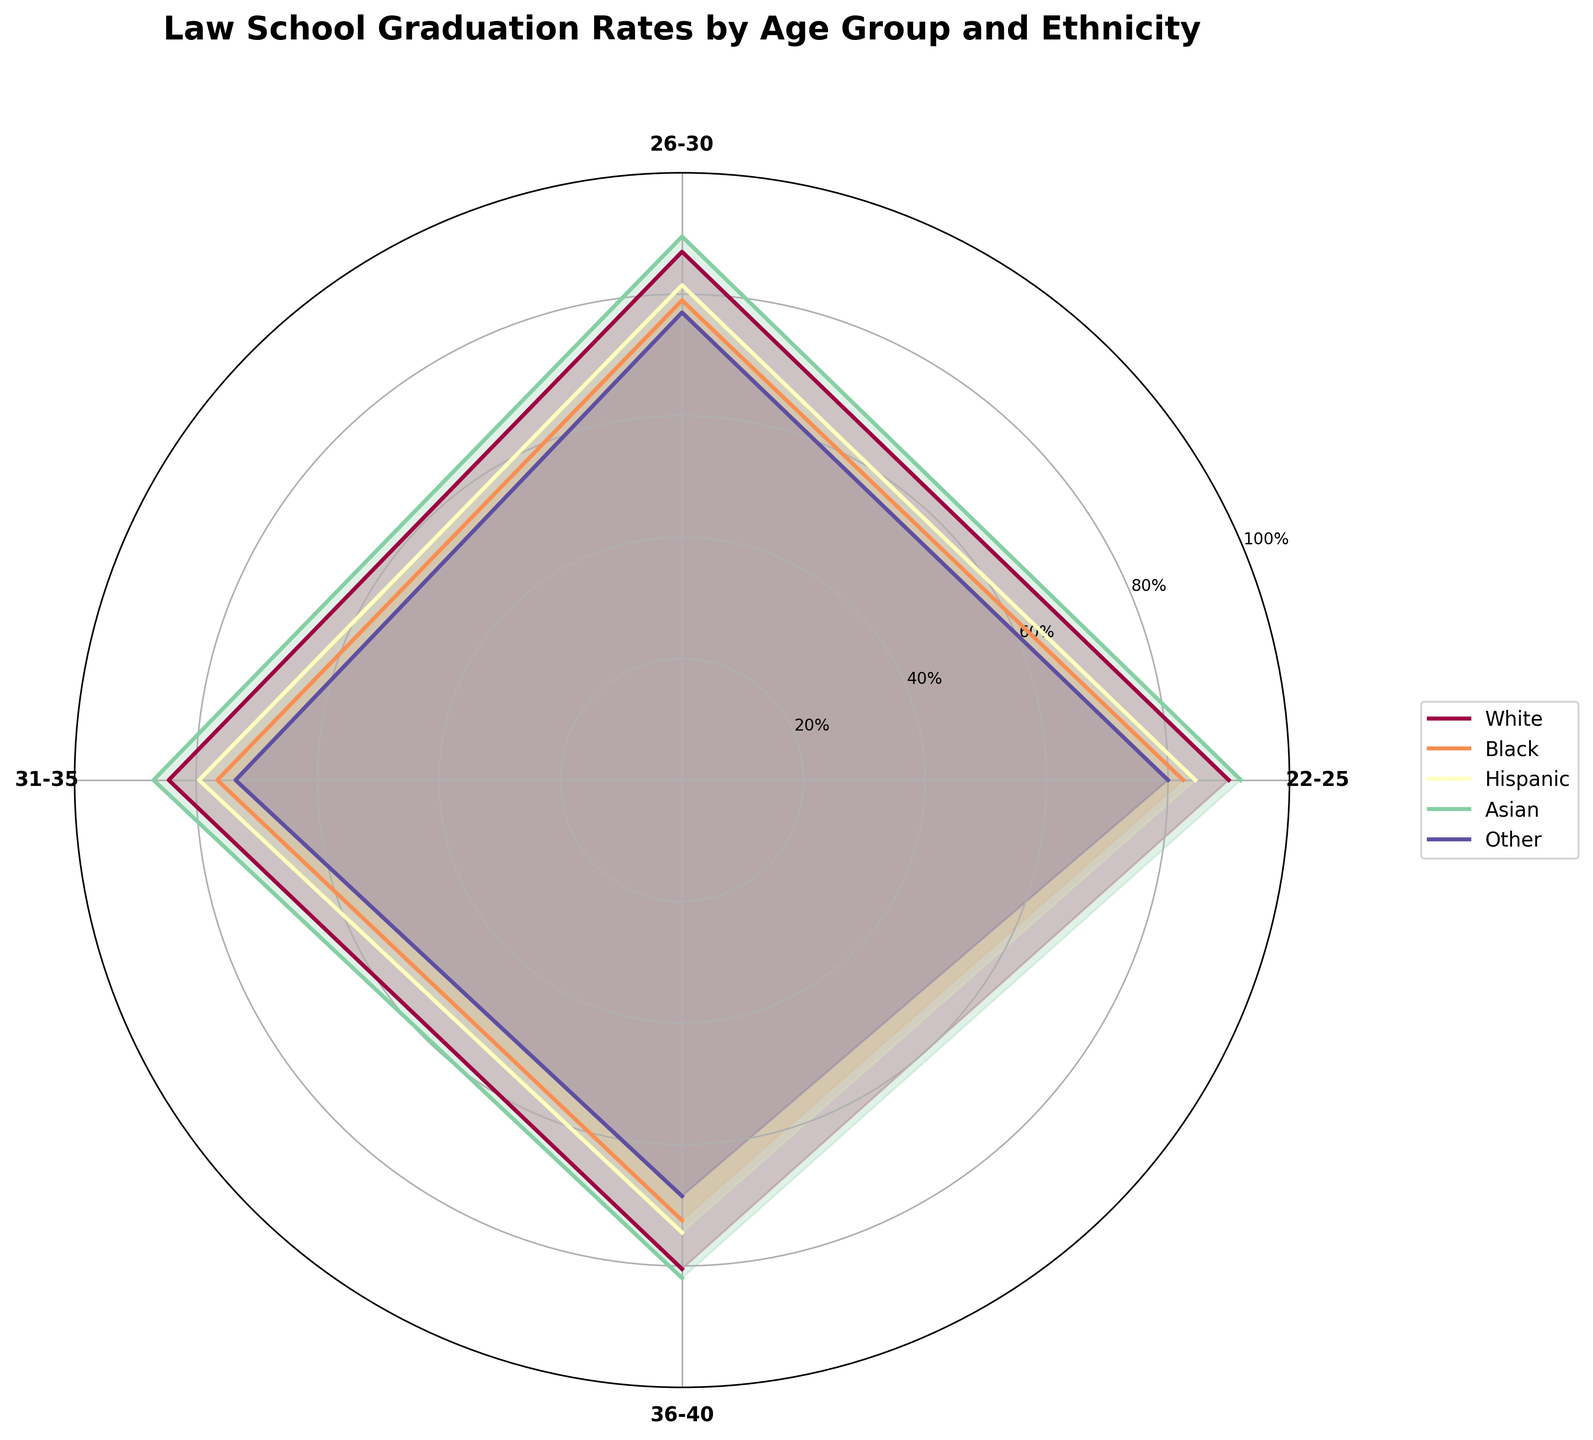What is the title of the plot? The title of the plot is positioned at the top and reads "Law School Graduation Rates by Age Group and Ethnicity".
Answer: Law School Graduation Rates by Age Group and Ethnicity What age group has the highest graduation rate among Asian females? Looking at the plot, the data for Asian females covers four age groups, and the highest point on the polar chart for Asian females is in the 22-25 age group.
Answer: 22-25 Which ethnic group has the lowest graduation rate in the 36-40 age group? Observing the 36-40 age section on the polar chart, the 'Other' ethnic group has the lowest graduation rate indicated by the smallest radius.
Answer: Other How does the graduation rate of Hispanic males aged 22-25 compare with that of Hispanic females aged 22-25? By comparing the radius lengths in the 22-25 age group for males and females, we can see that the graduation rate for Hispanic females is higher than that of Hispanic males.
Answer: Hispanic females have a higher rate What is the difference in graduation rates between Black males aged 31-35 and Black females aged 31-35? The plot shows the graduation rates for Black males and females in the 31-35 age group, which are 74% and 79%, respectively. The difference is calculated as 79 - 74 = 5%.
Answer: 5% Which gender generally has higher graduation rates in the 26-30 age group? Examining the 26-30 age sector of the plot, the radii for females are generally longer than those for males.
Answer: Females What is the average graduation rate for White males across all age groups? We calculate the average by summing the graduation rates of White males across all age groups (88+85+82+78) and dividing by 4, yielding an average of (88+85+82+78)/4 = 83.25%.
Answer: 83.25% How do the graduation rates of Asian females compare to Asian males across all age groups? By examining the polar chart, the radii for Asian females are consistently longer across all age groups compared to Asian males, indicating higher graduation rates for Asian females.
Answer: Asian females have higher rates What is the median graduation rate for all demographic groups aged 36-40? We list the graduation rates for all demographics aged 36-40 (78, 83, 70, 75, 73, 76, 80, 84, 66, 71), and find the median value, which falls between the 5th and 6th values in the ordered set: (75+76)/2 = 75.5%.
Answer: 75.5% Which age group shows the greatest disparity in graduation rates between males and females within the 'Other' ethnicity? By comparing the lengths of the male-centric and female-centric radii in each age group for 'Other', the greatest difference is found in the 22-25 age group, with males at 78% and females at 82%, showing a disparity of 4%.
Answer: 22-25 